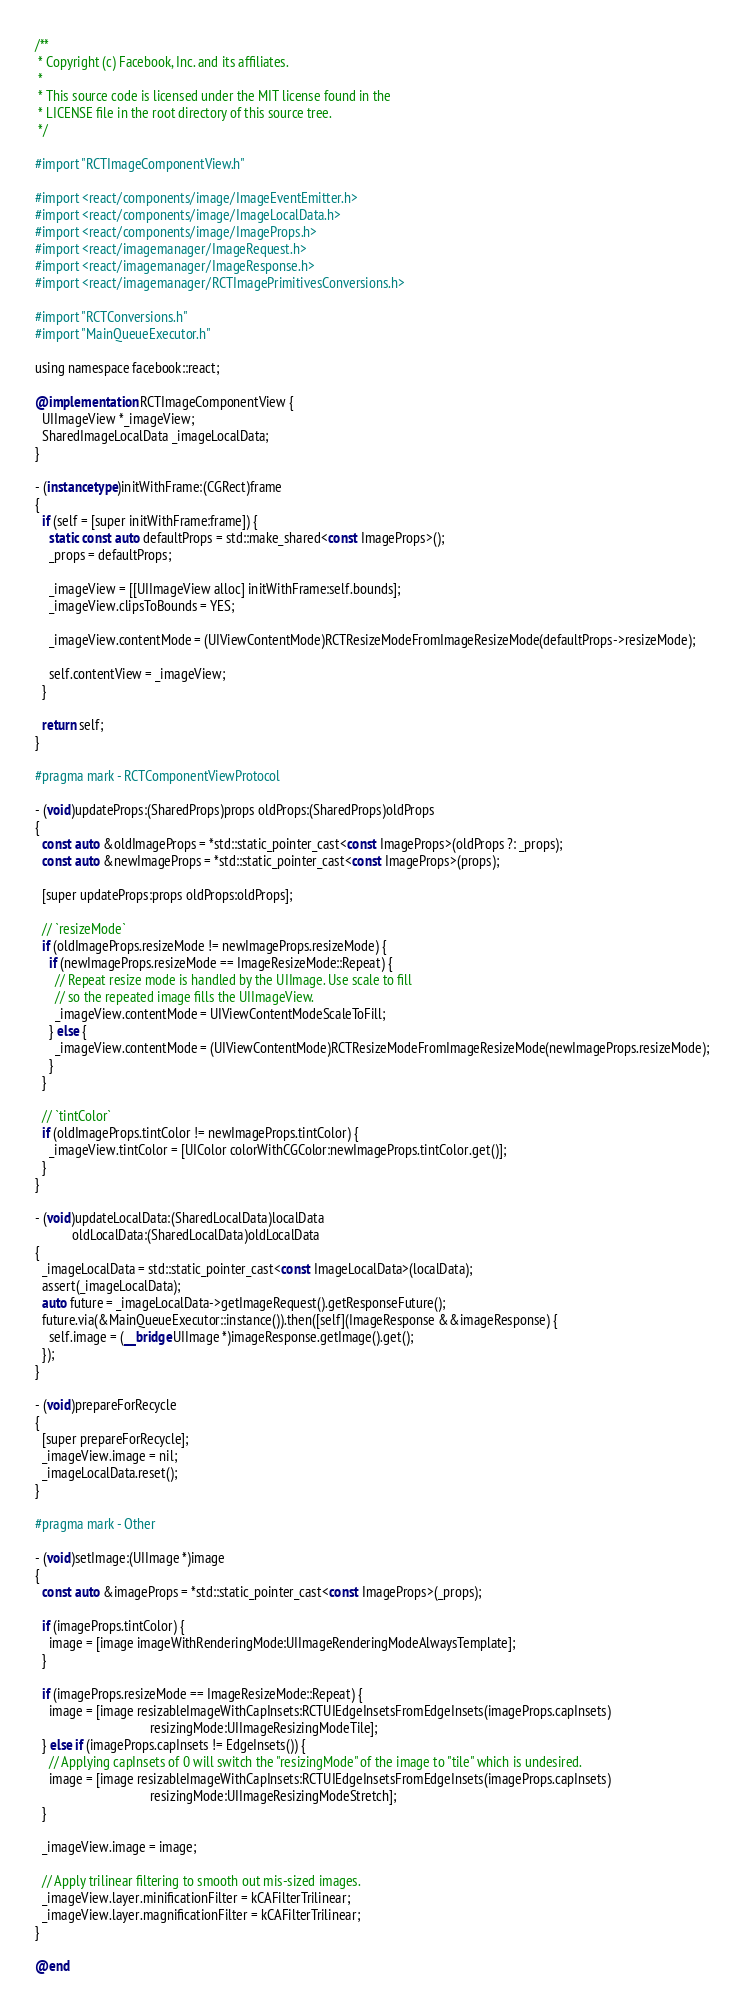<code> <loc_0><loc_0><loc_500><loc_500><_ObjectiveC_>/**
 * Copyright (c) Facebook, Inc. and its affiliates.
 *
 * This source code is licensed under the MIT license found in the
 * LICENSE file in the root directory of this source tree.
 */

#import "RCTImageComponentView.h"

#import <react/components/image/ImageEventEmitter.h>
#import <react/components/image/ImageLocalData.h>
#import <react/components/image/ImageProps.h>
#import <react/imagemanager/ImageRequest.h>
#import <react/imagemanager/ImageResponse.h>
#import <react/imagemanager/RCTImagePrimitivesConversions.h>

#import "RCTConversions.h"
#import "MainQueueExecutor.h"

using namespace facebook::react;

@implementation RCTImageComponentView {
  UIImageView *_imageView;
  SharedImageLocalData _imageLocalData;
}

- (instancetype)initWithFrame:(CGRect)frame
{
  if (self = [super initWithFrame:frame]) {
    static const auto defaultProps = std::make_shared<const ImageProps>();
    _props = defaultProps;

    _imageView = [[UIImageView alloc] initWithFrame:self.bounds];
    _imageView.clipsToBounds = YES;

    _imageView.contentMode = (UIViewContentMode)RCTResizeModeFromImageResizeMode(defaultProps->resizeMode);

    self.contentView = _imageView;
  }

  return self;
}

#pragma mark - RCTComponentViewProtocol

- (void)updateProps:(SharedProps)props oldProps:(SharedProps)oldProps
{
  const auto &oldImageProps = *std::static_pointer_cast<const ImageProps>(oldProps ?: _props);
  const auto &newImageProps = *std::static_pointer_cast<const ImageProps>(props);

  [super updateProps:props oldProps:oldProps];

  // `resizeMode`
  if (oldImageProps.resizeMode != newImageProps.resizeMode) {
    if (newImageProps.resizeMode == ImageResizeMode::Repeat) {
      // Repeat resize mode is handled by the UIImage. Use scale to fill
      // so the repeated image fills the UIImageView.
      _imageView.contentMode = UIViewContentModeScaleToFill;
    } else {
      _imageView.contentMode = (UIViewContentMode)RCTResizeModeFromImageResizeMode(newImageProps.resizeMode);
    }
  }

  // `tintColor`
  if (oldImageProps.tintColor != newImageProps.tintColor) {
    _imageView.tintColor = [UIColor colorWithCGColor:newImageProps.tintColor.get()];
  }
}

- (void)updateLocalData:(SharedLocalData)localData
           oldLocalData:(SharedLocalData)oldLocalData
{
  _imageLocalData = std::static_pointer_cast<const ImageLocalData>(localData);
  assert(_imageLocalData);
  auto future = _imageLocalData->getImageRequest().getResponseFuture();
  future.via(&MainQueueExecutor::instance()).then([self](ImageResponse &&imageResponse) {
    self.image = (__bridge UIImage *)imageResponse.getImage().get();
  });
}

- (void)prepareForRecycle
{
  [super prepareForRecycle];
  _imageView.image = nil;
  _imageLocalData.reset();
}

#pragma mark - Other

- (void)setImage:(UIImage *)image
{
  const auto &imageProps = *std::static_pointer_cast<const ImageProps>(_props);

  if (imageProps.tintColor) {
    image = [image imageWithRenderingMode:UIImageRenderingModeAlwaysTemplate];
  }

  if (imageProps.resizeMode == ImageResizeMode::Repeat) {
    image = [image resizableImageWithCapInsets:RCTUIEdgeInsetsFromEdgeInsets(imageProps.capInsets)
                                  resizingMode:UIImageResizingModeTile];
  } else if (imageProps.capInsets != EdgeInsets()) {
    // Applying capInsets of 0 will switch the "resizingMode" of the image to "tile" which is undesired.
    image = [image resizableImageWithCapInsets:RCTUIEdgeInsetsFromEdgeInsets(imageProps.capInsets)
                                  resizingMode:UIImageResizingModeStretch];
  }

  _imageView.image = image;

  // Apply trilinear filtering to smooth out mis-sized images.
  _imageView.layer.minificationFilter = kCAFilterTrilinear;
  _imageView.layer.magnificationFilter = kCAFilterTrilinear;
}

@end
</code> 